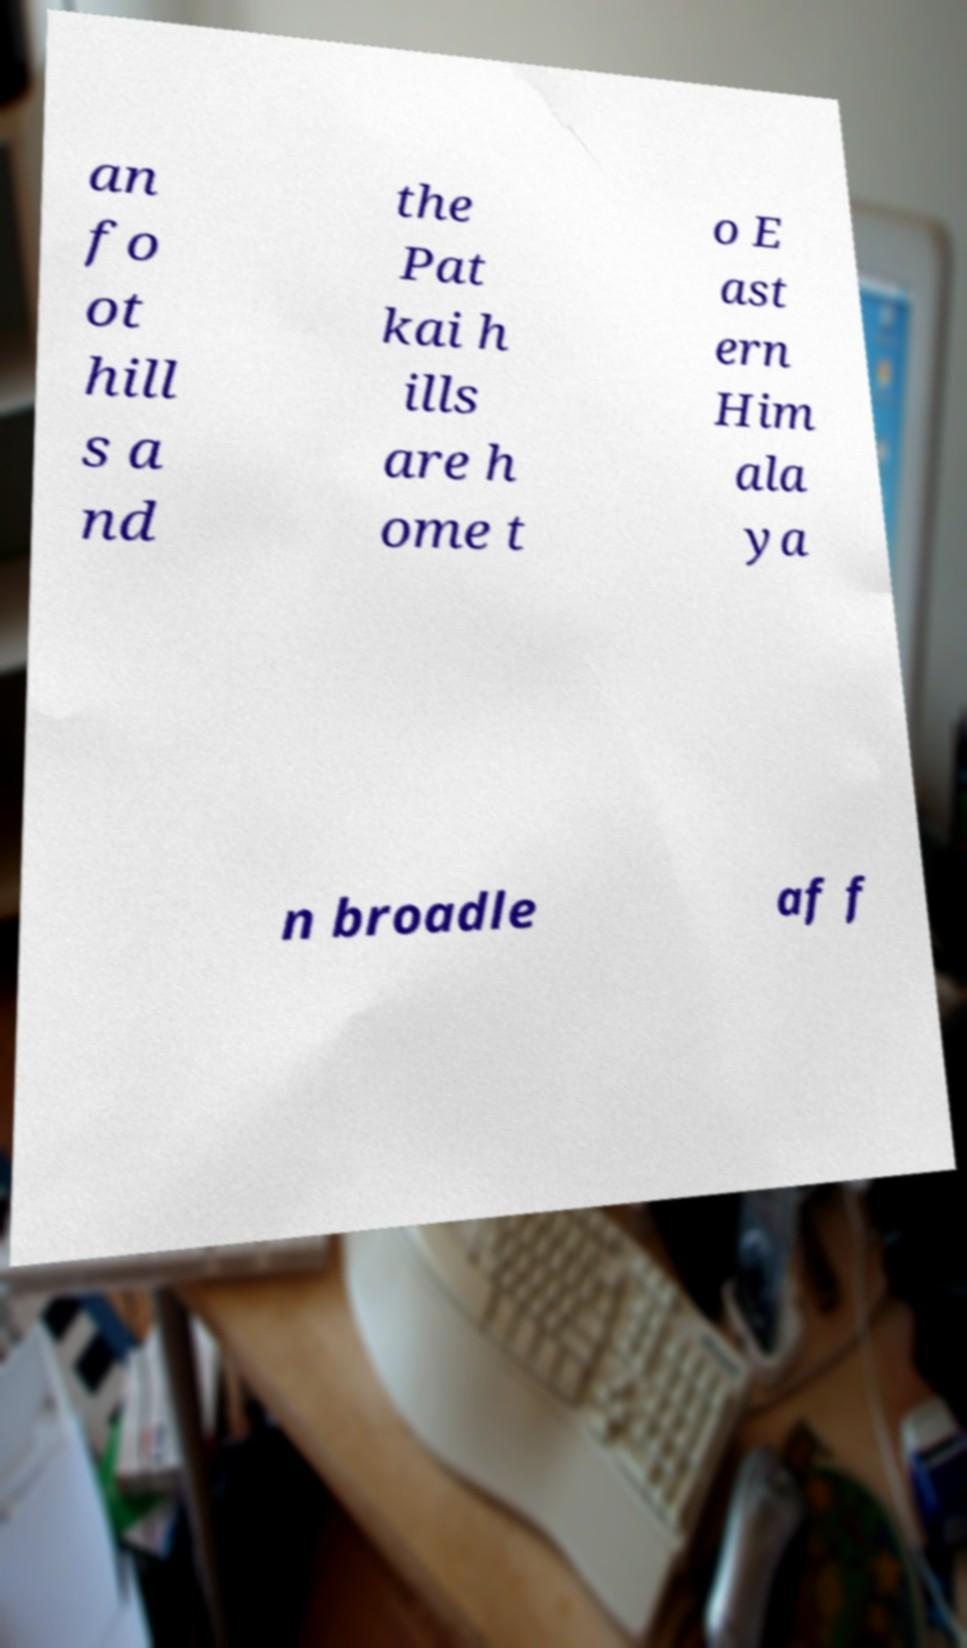Could you extract and type out the text from this image? an fo ot hill s a nd the Pat kai h ills are h ome t o E ast ern Him ala ya n broadle af f 